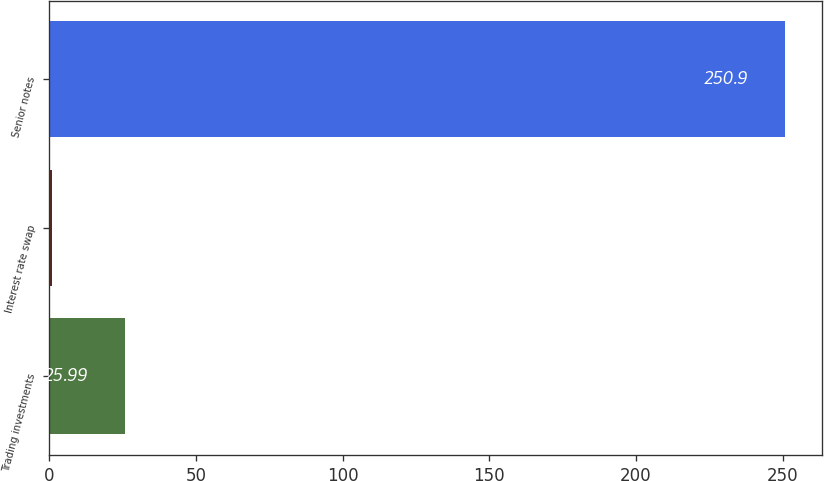<chart> <loc_0><loc_0><loc_500><loc_500><bar_chart><fcel>Trading investments<fcel>Interest rate swap<fcel>Senior notes<nl><fcel>25.99<fcel>1<fcel>250.9<nl></chart> 